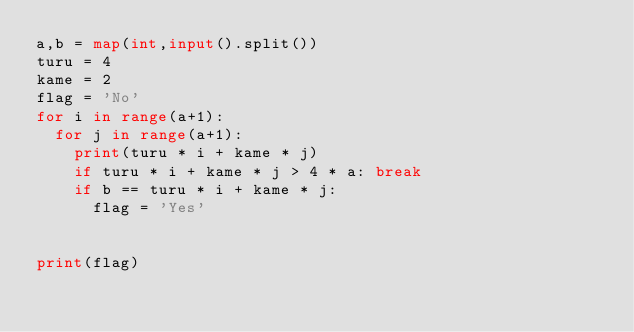<code> <loc_0><loc_0><loc_500><loc_500><_Python_>a,b = map(int,input().split())
turu = 4
kame = 2
flag = 'No'
for i in range(a+1):
  for j in range(a+1):
    print(turu * i + kame * j)
    if turu * i + kame * j > 4 * a: break
    if b == turu * i + kame * j:
      flag = 'Yes'
  

print(flag)</code> 